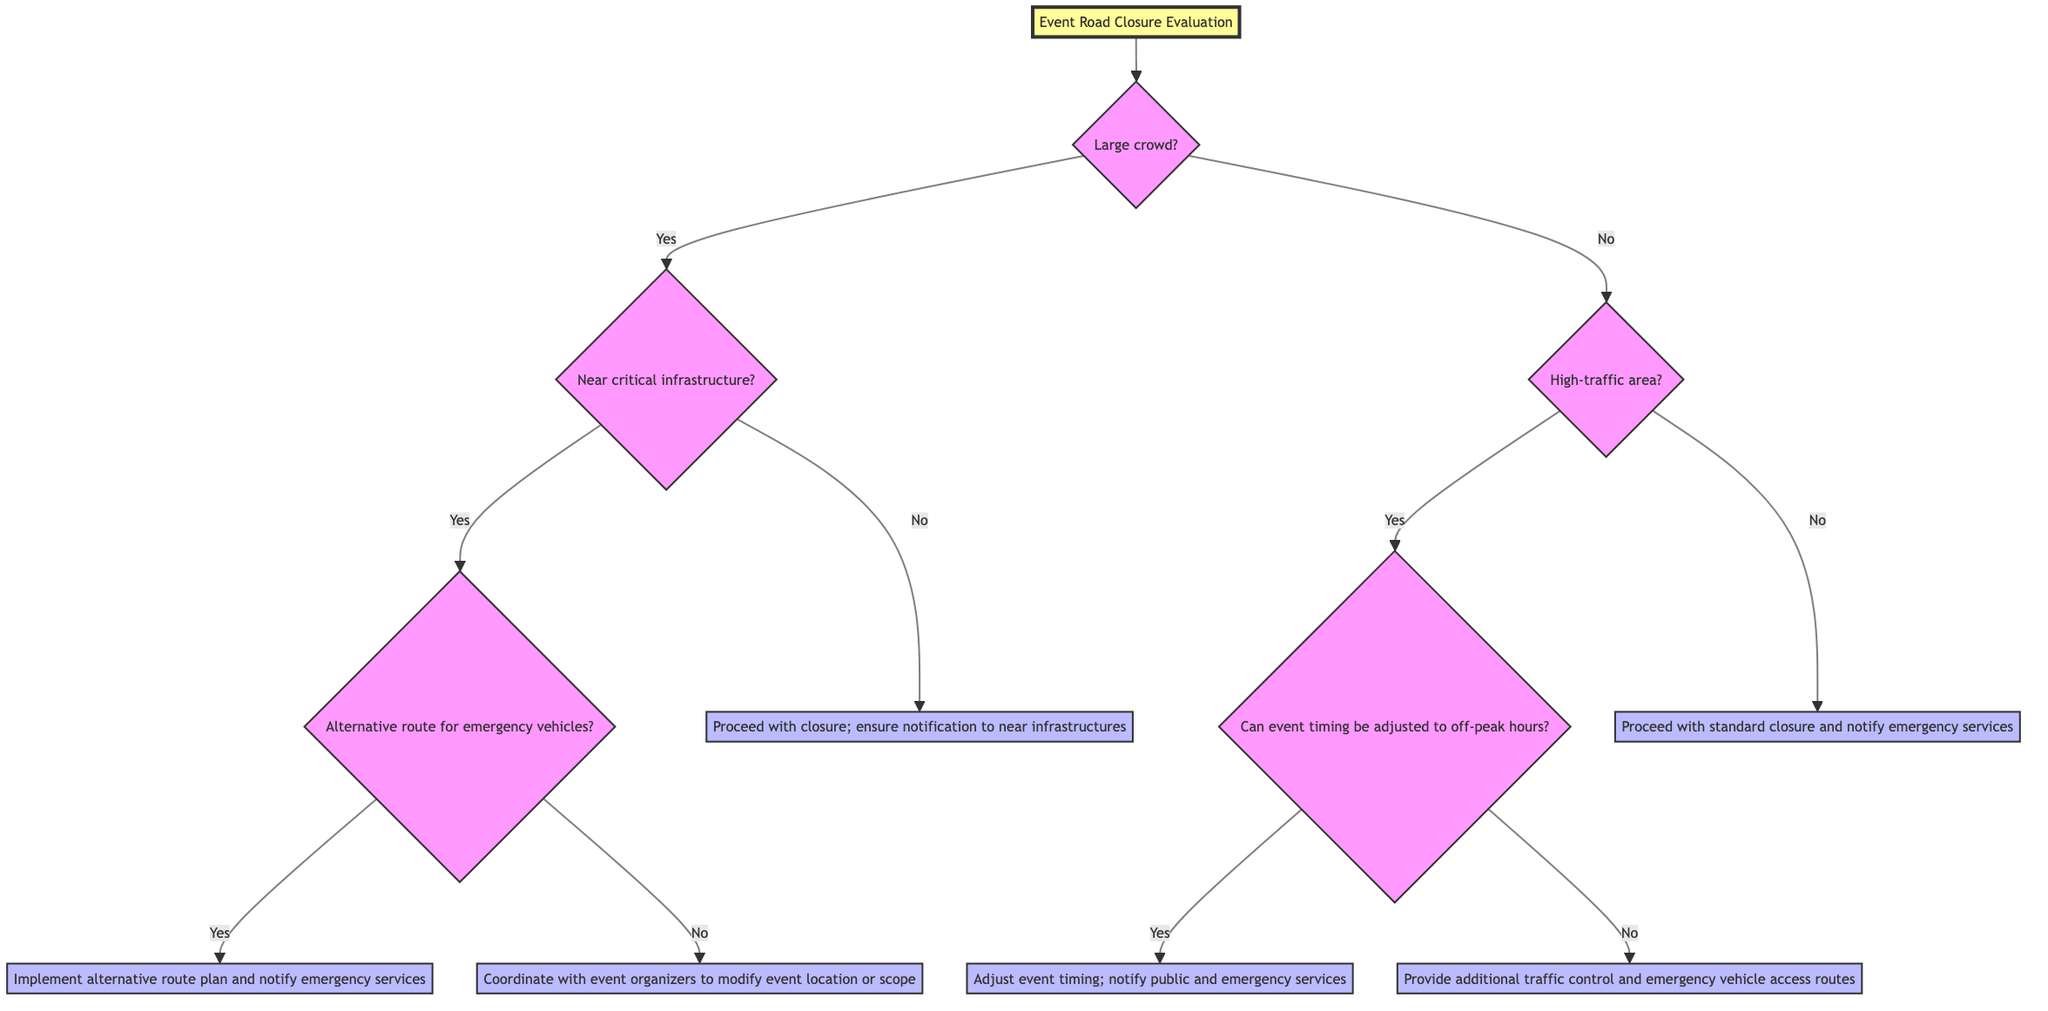Is there a starting point in the diagram? Yes, the starting point is "Event Road Closure Evaluation." It's the first node in the decision tree and represents the initial evaluation process for event road closures.
Answer: Event Road Closure Evaluation How many main questions are there in the diagram? The diagram contains three main questions: "Is the event expected to draw a large crowd?", "Is the event in a high-traffic area?", and "Is the event location near critical infrastructure?". These questions branch out to different outcomes.
Answer: Three What action is taken if the event does not draw a large crowd? If the event does not draw a large crowd, the next question asked is whether the event is in a high-traffic area. If this condition is met, it leads to further questions regarding timing adjustments.
Answer: Proceed with standard closure and notify emergency services What happens if the event has a large crowd but no alternative route for emergency vehicles? If the event draws a large crowd and no alternative route exists for emergency vehicles, the action taken is to coordinate with event organizers to modify the event location or scope.
Answer: Coordinate with event organizers to modify event location or scope If the event is in a high-traffic area and the timing can be adjusted, what action should be taken? If the event is in a high-traffic area and it is possible to adjust the timing to off-peak hours, the action to be taken is to adjust the event timing and notify the public and emergency services.
Answer: Adjust event timing; notify public and emergency services What is the decision flow following the answer "Yes" to the question about critical infrastructure? If the event location is near critical infrastructure and the answer is "Yes," the next question is whether there is an alternative route for emergency vehicles. This further branches into actions based on the presence or absence of such a route.
Answer: Is there an alternative route for emergency vehicles? 